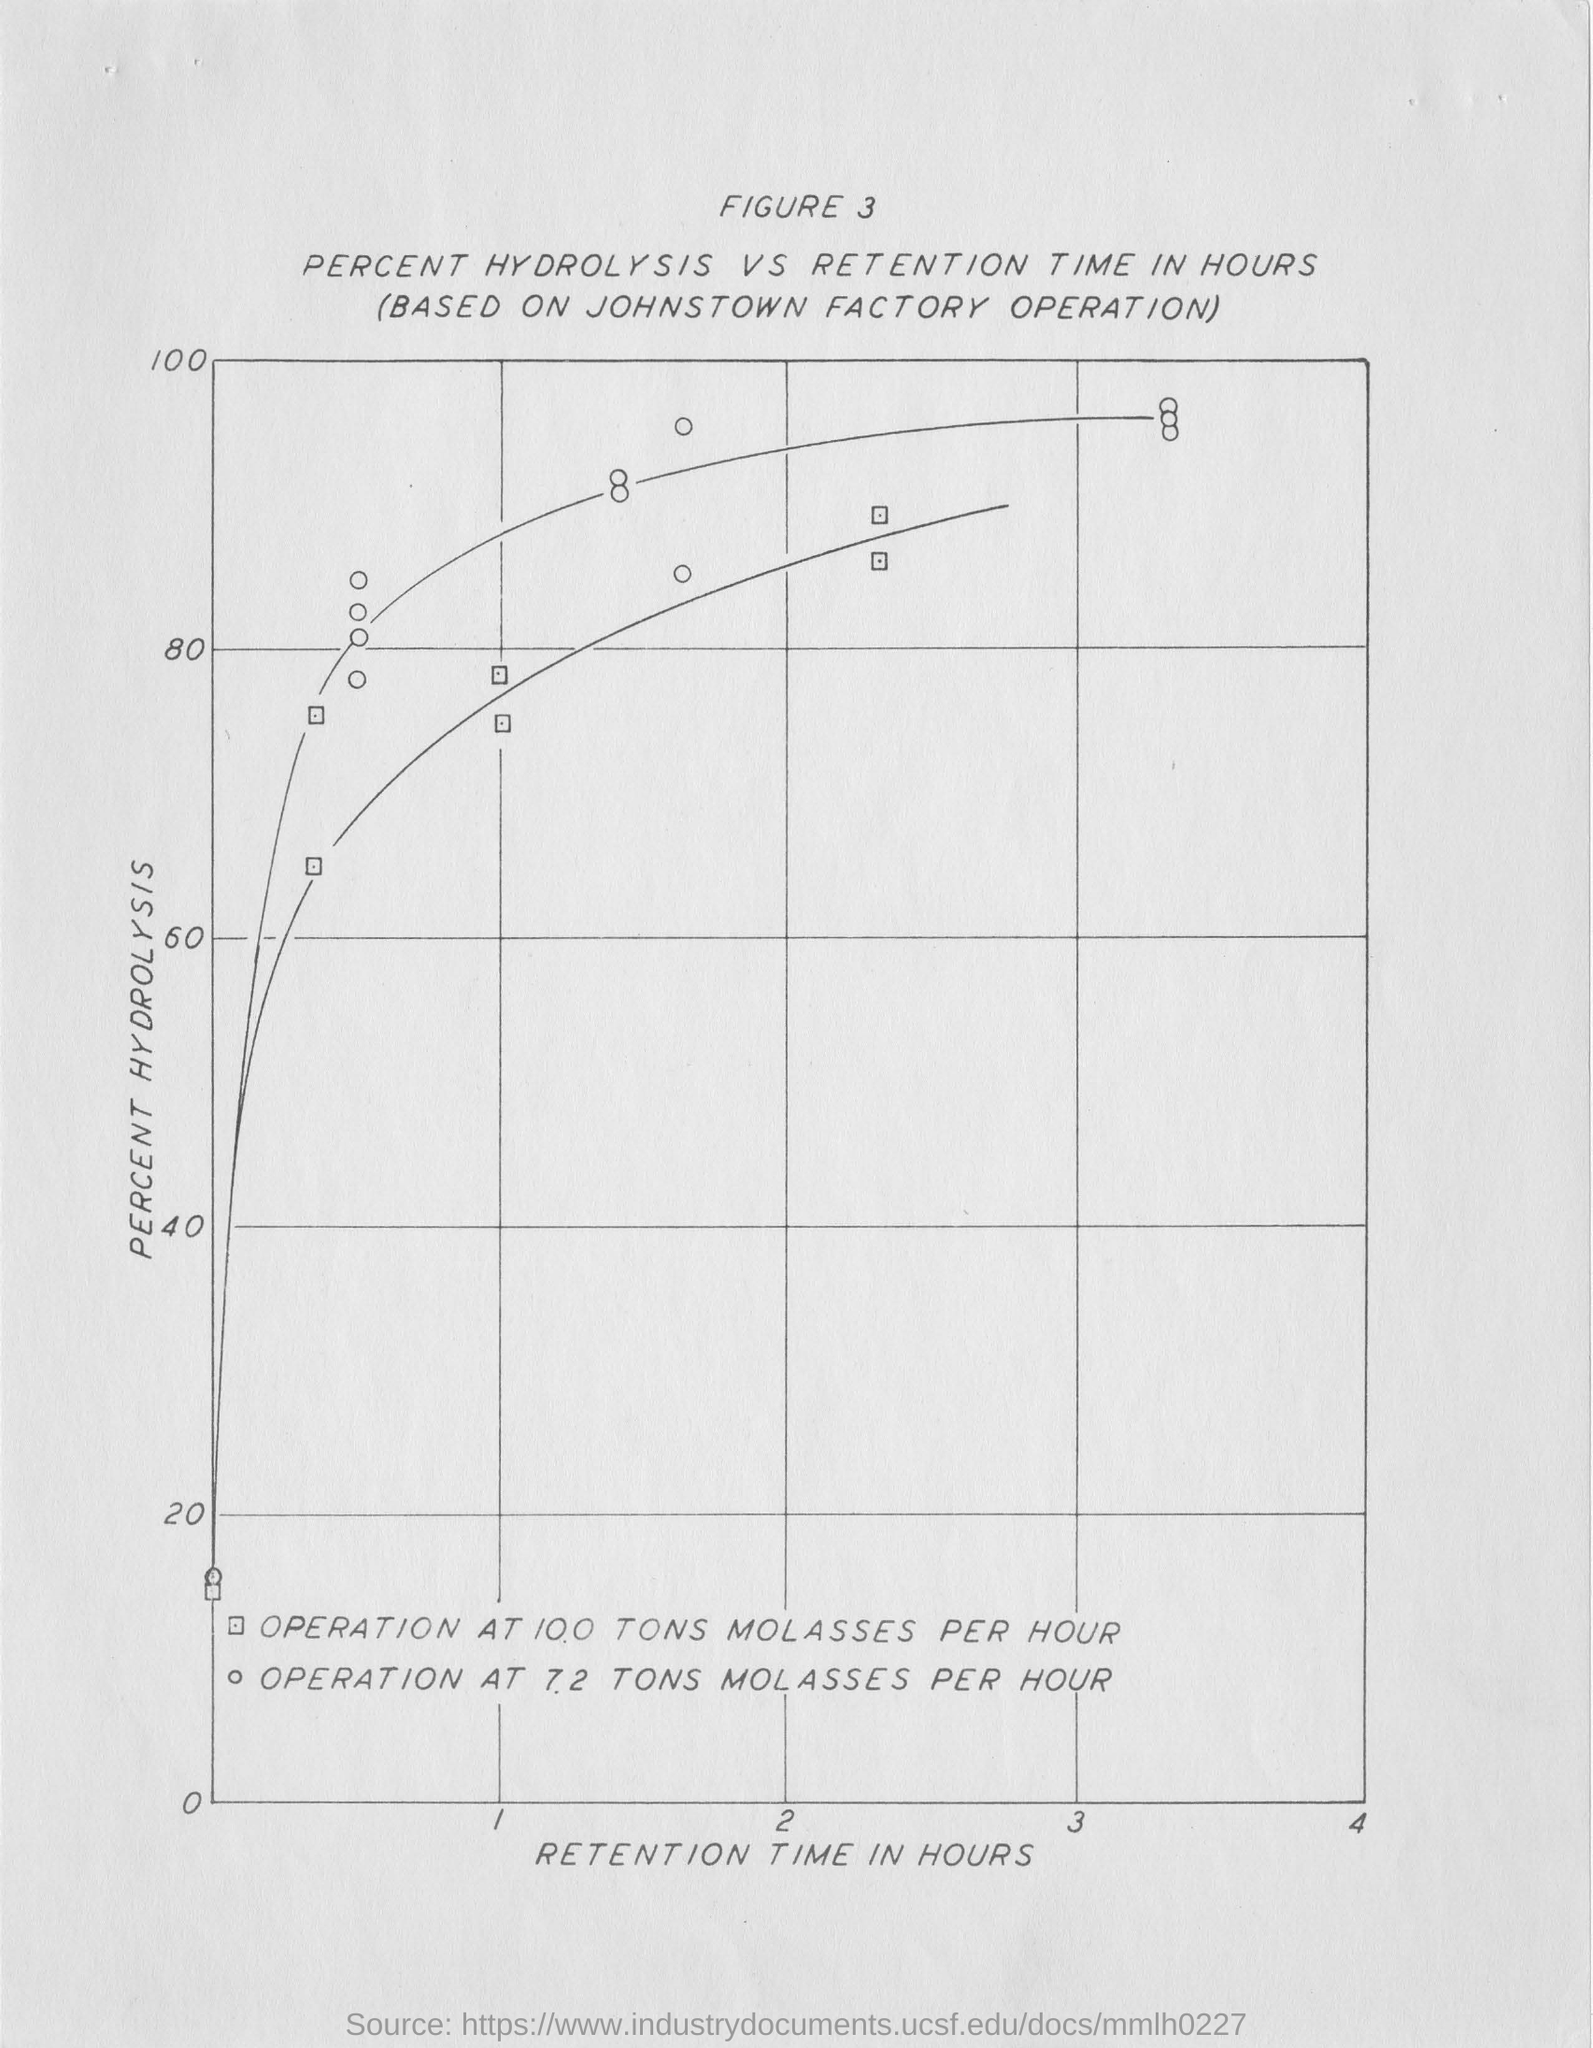What is plotted in the x-axis?
Offer a terse response. Retention time in hours. What is plotted in the y-axis?
Your response must be concise. Percent Hydrolysis. 